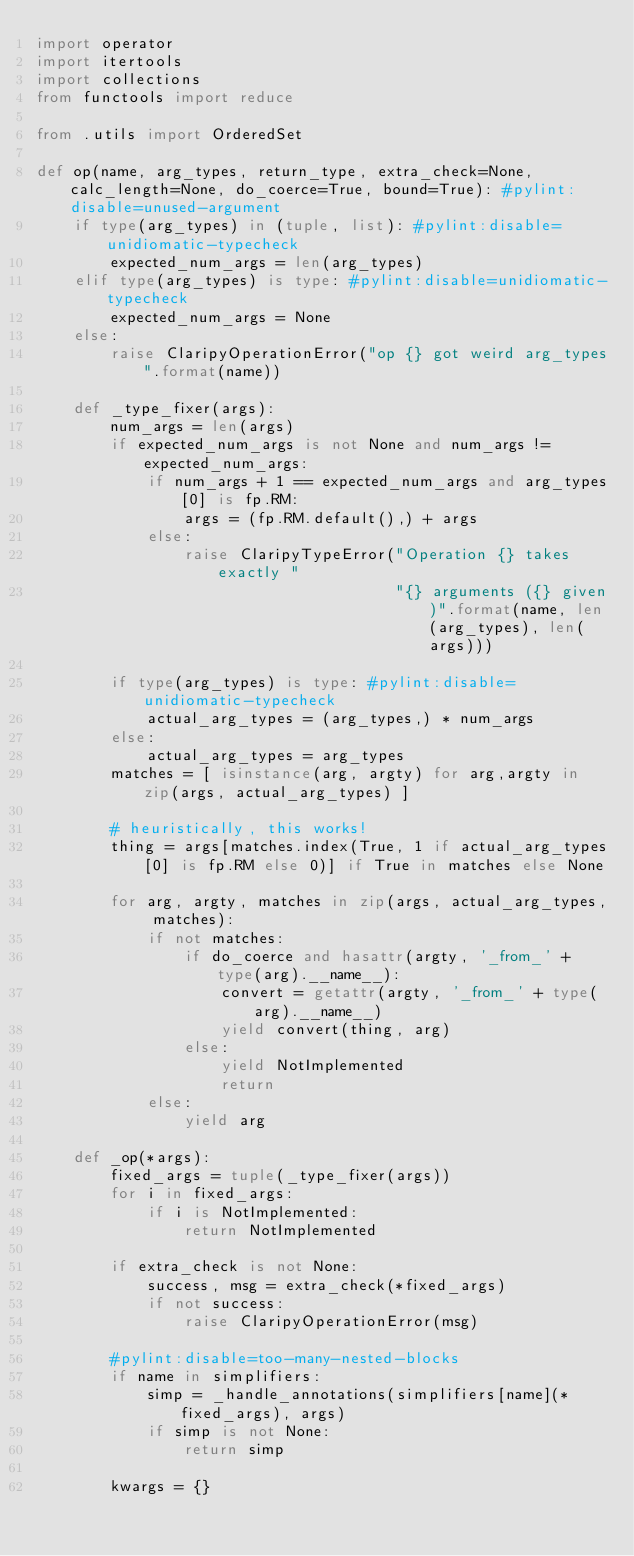<code> <loc_0><loc_0><loc_500><loc_500><_Python_>import operator
import itertools
import collections
from functools import reduce

from .utils import OrderedSet

def op(name, arg_types, return_type, extra_check=None, calc_length=None, do_coerce=True, bound=True): #pylint:disable=unused-argument
    if type(arg_types) in (tuple, list): #pylint:disable=unidiomatic-typecheck
        expected_num_args = len(arg_types)
    elif type(arg_types) is type: #pylint:disable=unidiomatic-typecheck
        expected_num_args = None
    else:
        raise ClaripyOperationError("op {} got weird arg_types".format(name))

    def _type_fixer(args):
        num_args = len(args)
        if expected_num_args is not None and num_args != expected_num_args:
            if num_args + 1 == expected_num_args and arg_types[0] is fp.RM:
                args = (fp.RM.default(),) + args
            else:
                raise ClaripyTypeError("Operation {} takes exactly "
                                       "{} arguments ({} given)".format(name, len(arg_types), len(args)))

        if type(arg_types) is type: #pylint:disable=unidiomatic-typecheck
            actual_arg_types = (arg_types,) * num_args
        else:
            actual_arg_types = arg_types
        matches = [ isinstance(arg, argty) for arg,argty in zip(args, actual_arg_types) ]

        # heuristically, this works!
        thing = args[matches.index(True, 1 if actual_arg_types[0] is fp.RM else 0)] if True in matches else None

        for arg, argty, matches in zip(args, actual_arg_types, matches):
            if not matches:
                if do_coerce and hasattr(argty, '_from_' + type(arg).__name__):
                    convert = getattr(argty, '_from_' + type(arg).__name__)
                    yield convert(thing, arg)
                else:
                    yield NotImplemented
                    return
            else:
                yield arg

    def _op(*args):
        fixed_args = tuple(_type_fixer(args))
        for i in fixed_args:
            if i is NotImplemented:
                return NotImplemented

        if extra_check is not None:
            success, msg = extra_check(*fixed_args)
            if not success:
                raise ClaripyOperationError(msg)

        #pylint:disable=too-many-nested-blocks
        if name in simplifiers:
            simp = _handle_annotations(simplifiers[name](*fixed_args), args)
            if simp is not None:
                return simp

        kwargs = {}</code> 